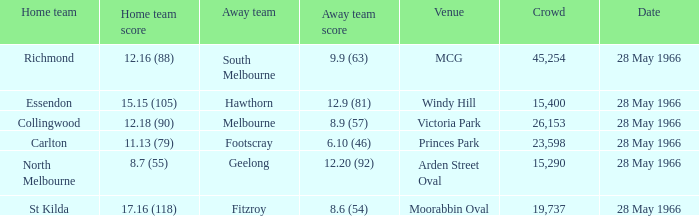Which group has an away team score of 19737.0. 